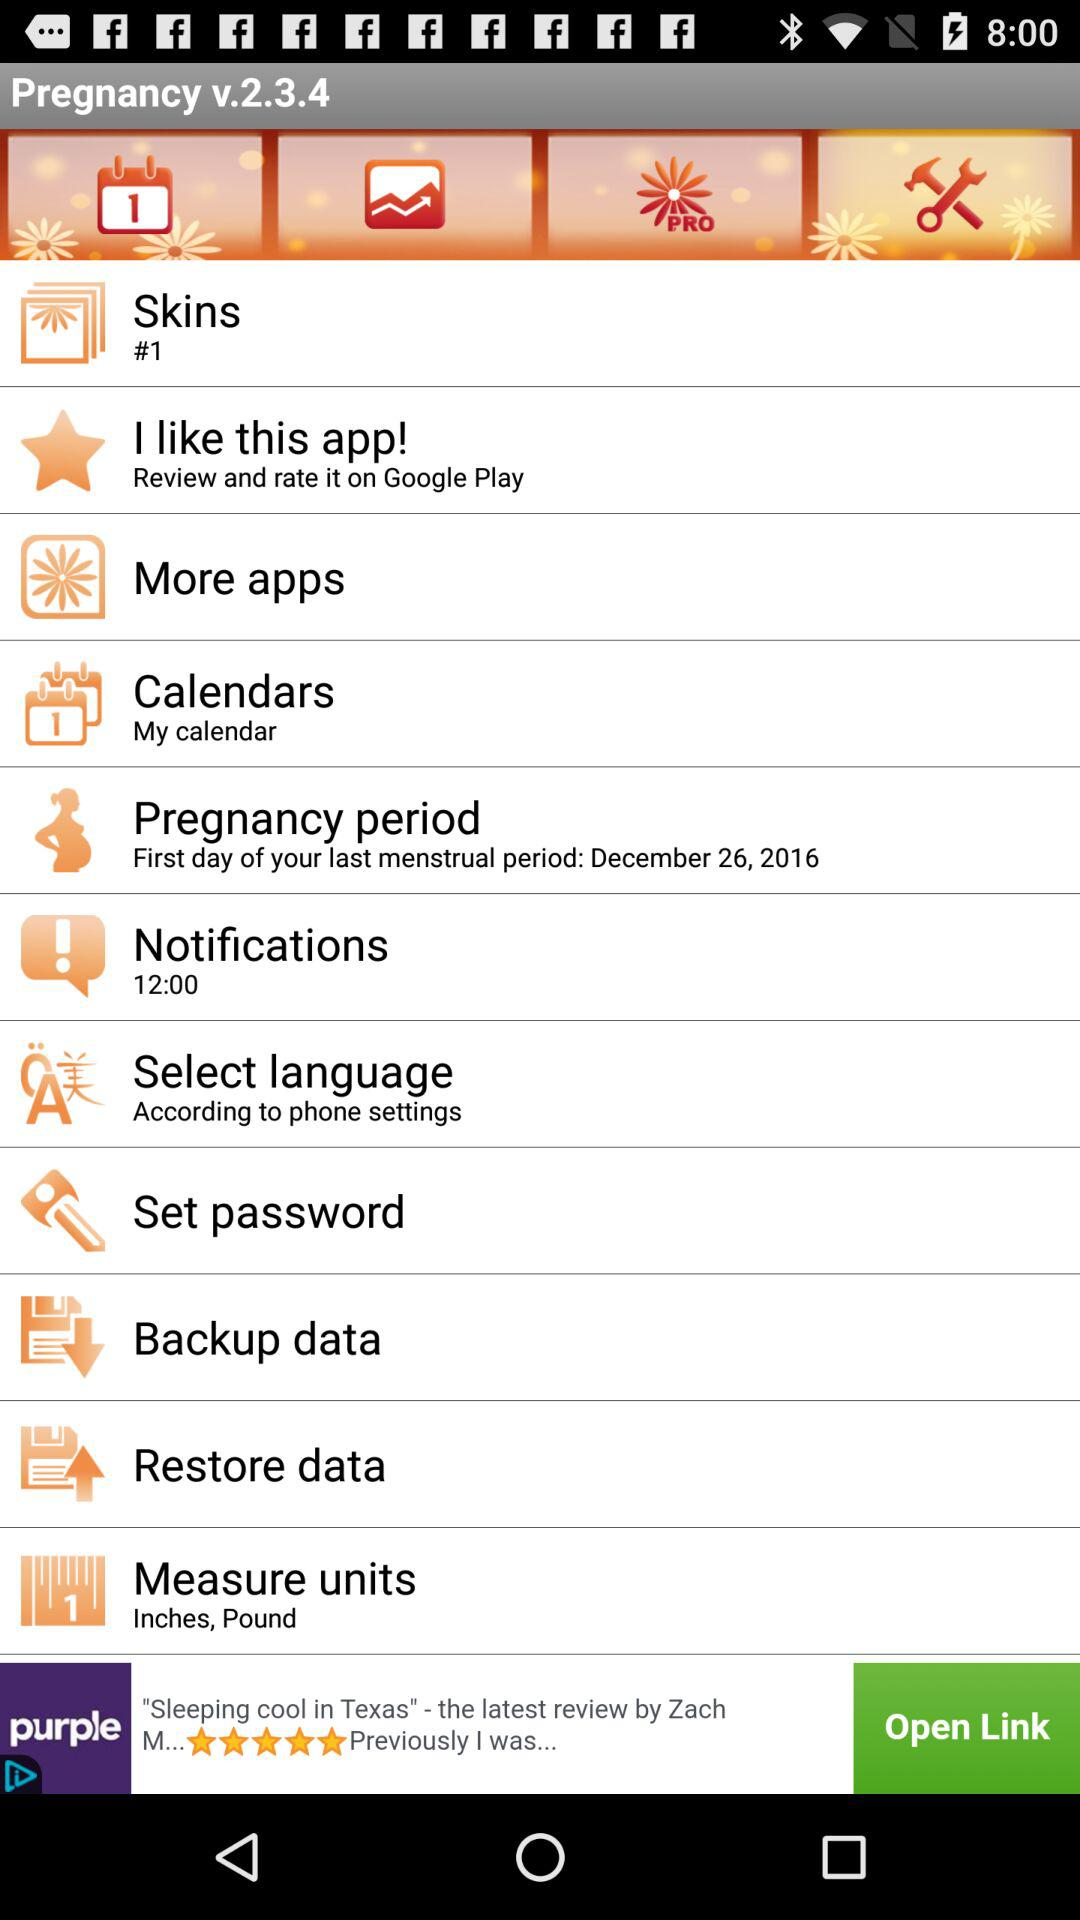What's the "Notifications" time? The "Notifications" time is 12:00. 